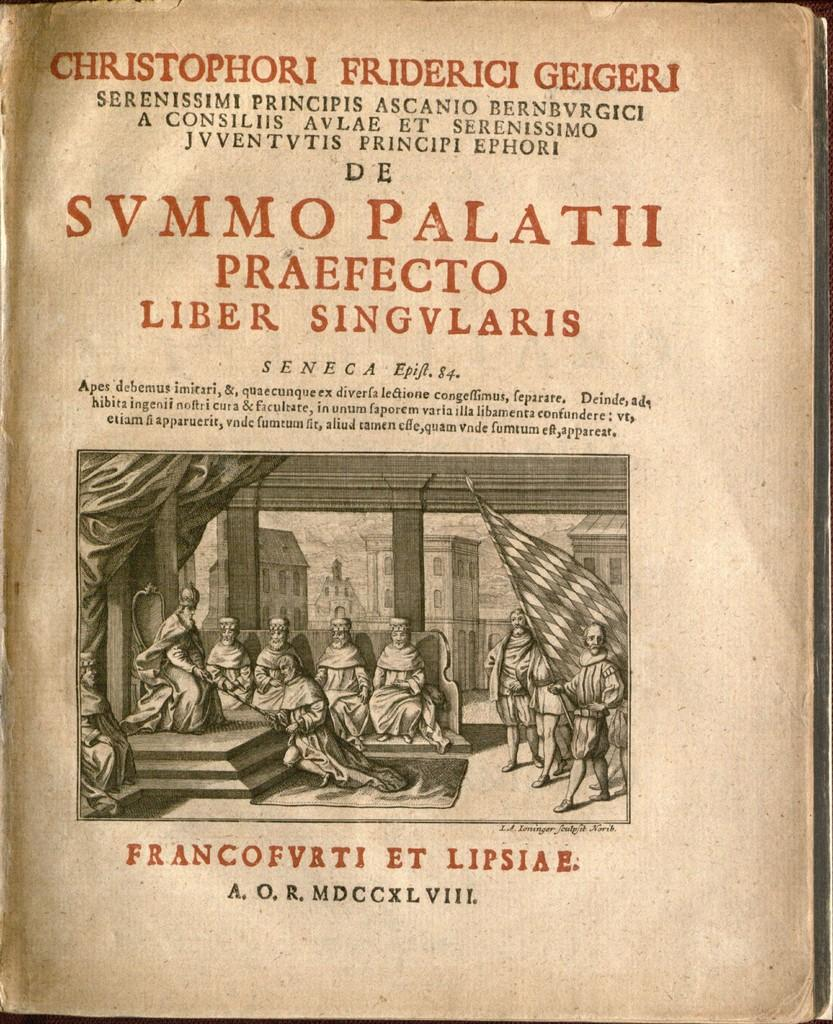<image>
Render a clear and concise summary of the photo. A page of a very old book has the Roman numeral MDCCXLVIII at the bottom. 